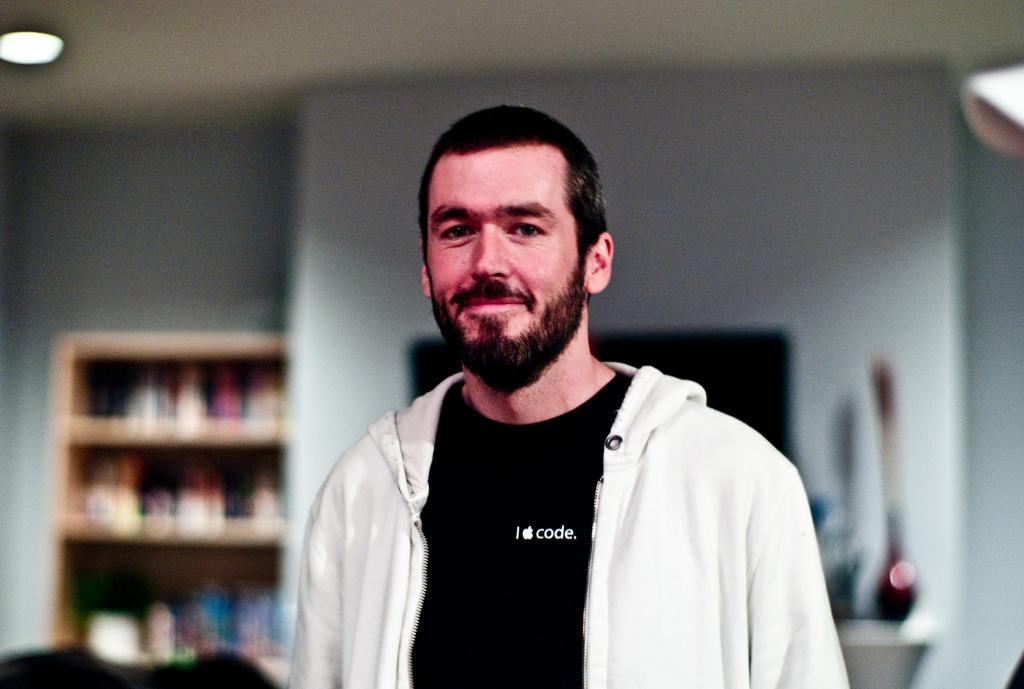<image>
Render a clear and concise summary of the photo. A man wearing a white hoodie and a black T-shirt with the Apple logo which indicates he might be an employee. 